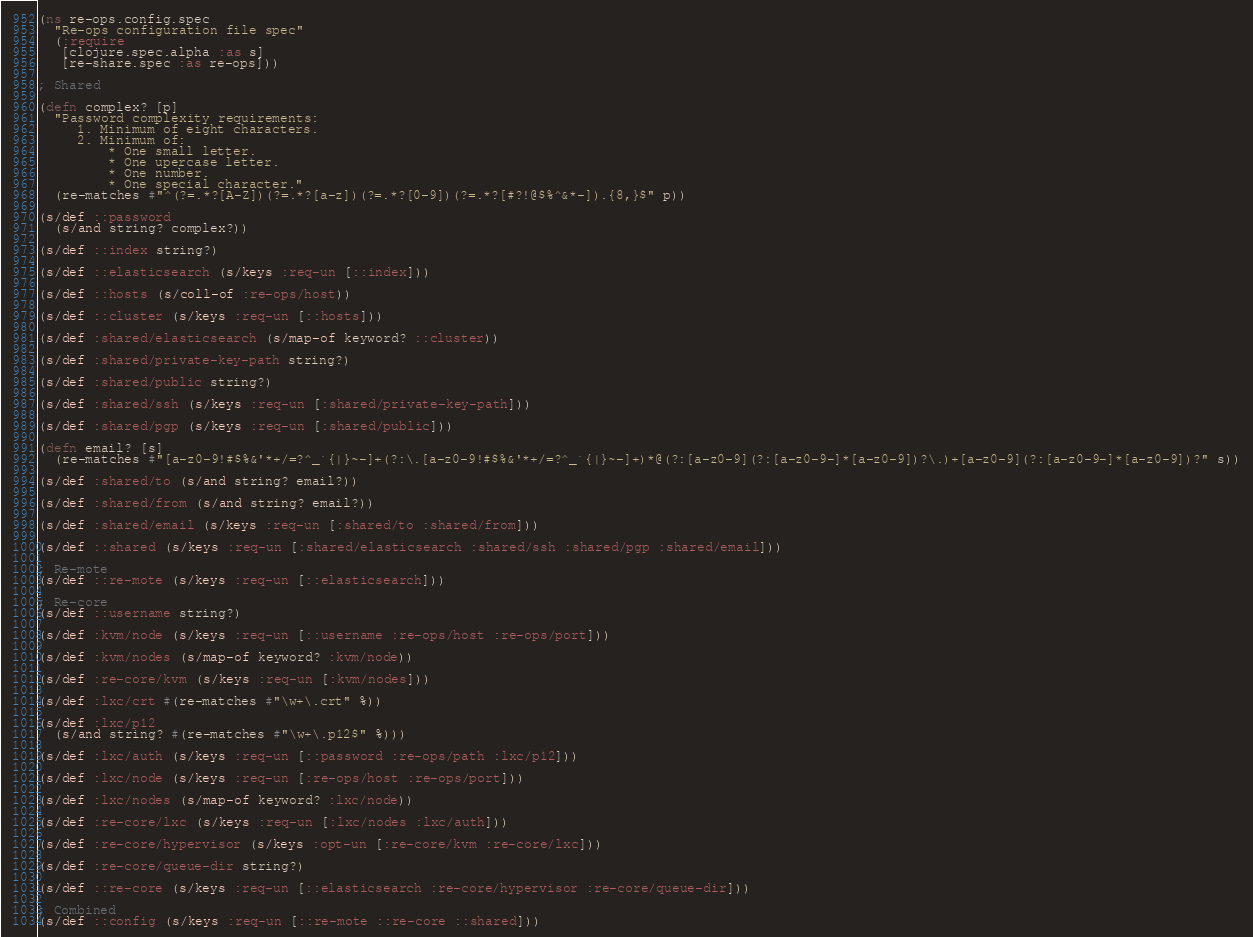<code> <loc_0><loc_0><loc_500><loc_500><_Clojure_>(ns re-ops.config.spec
  "Re-ops configuration file spec"
  (:require
   [clojure.spec.alpha :as s]
   [re-share.spec :as re-ops]))

; Shared

(defn complex? [p]
  "Password complexity requirements:
     1. Minimum of eight characters.
     2. Minimum of:
         * One small letter.
         * One upercase letter.
         * One number.
         * One special character."
  (re-matches #"^(?=.*?[A-Z])(?=.*?[a-z])(?=.*?[0-9])(?=.*?[#?!@$%^&*-]).{8,}$" p))

(s/def ::password
  (s/and string? complex?))

(s/def ::index string?)

(s/def ::elasticsearch (s/keys :req-un [::index]))

(s/def ::hosts (s/coll-of :re-ops/host))

(s/def ::cluster (s/keys :req-un [::hosts]))

(s/def :shared/elasticsearch (s/map-of keyword? ::cluster))

(s/def :shared/private-key-path string?)

(s/def :shared/public string?)

(s/def :shared/ssh (s/keys :req-un [:shared/private-key-path]))

(s/def :shared/pgp (s/keys :req-un [:shared/public]))

(defn email? [s]
  (re-matches #"[a-z0-9!#$%&'*+/=?^_`{|}~-]+(?:\.[a-z0-9!#$%&'*+/=?^_`{|}~-]+)*@(?:[a-z0-9](?:[a-z0-9-]*[a-z0-9])?\.)+[a-z0-9](?:[a-z0-9-]*[a-z0-9])?" s))

(s/def :shared/to (s/and string? email?))

(s/def :shared/from (s/and string? email?))

(s/def :shared/email (s/keys :req-un [:shared/to :shared/from]))

(s/def ::shared (s/keys :req-un [:shared/elasticsearch :shared/ssh :shared/pgp :shared/email]))

; Re-mote
(s/def ::re-mote (s/keys :req-un [::elasticsearch]))

; Re-core
(s/def ::username string?)

(s/def :kvm/node (s/keys :req-un [::username :re-ops/host :re-ops/port]))

(s/def :kvm/nodes (s/map-of keyword? :kvm/node))

(s/def :re-core/kvm (s/keys :req-un [:kvm/nodes]))

(s/def :lxc/crt #(re-matches #"\w+\.crt" %))

(s/def :lxc/p12
  (s/and string? #(re-matches #"\w+\.p12$" %)))

(s/def :lxc/auth (s/keys :req-un [::password :re-ops/path :lxc/p12]))

(s/def :lxc/node (s/keys :req-un [:re-ops/host :re-ops/port]))

(s/def :lxc/nodes (s/map-of keyword? :lxc/node))

(s/def :re-core/lxc (s/keys :req-un [:lxc/nodes :lxc/auth]))

(s/def :re-core/hypervisor (s/keys :opt-un [:re-core/kvm :re-core/lxc]))

(s/def :re-core/queue-dir string?)

(s/def ::re-core (s/keys :req-un [::elasticsearch :re-core/hypervisor :re-core/queue-dir]))

; Combined
(s/def ::config (s/keys :req-un [::re-mote ::re-core ::shared]))

</code> 